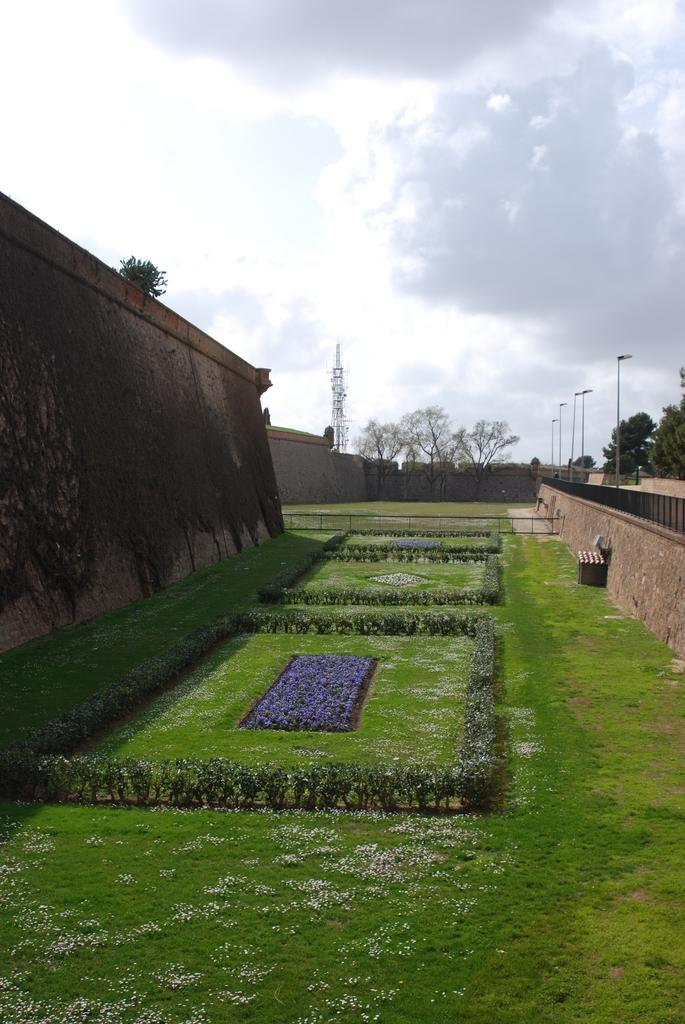What can be seen on both sides of the image? There are huge walls on both the right and left sides of the image. What is present in the middle of the image? There are plants on the surface of the grass in the middle of the wall. What is visible in the background of the image? There is a sky visible in the background of the image. What type of popcorn can be seen growing on the wall in the image? There is no popcorn present in the image; it features a wall with plants on the grass in the middle. How many masses are visible in the image? There is no reference to a mass in the image; it features a wall with plants on the grass in the middle. 